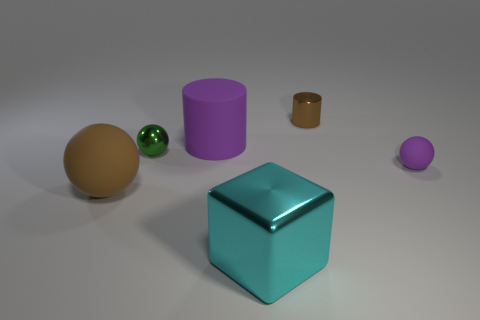Add 3 tiny rubber balls. How many objects exist? 9 Subtract all cubes. How many objects are left? 5 Add 4 brown matte spheres. How many brown matte spheres are left? 5 Add 1 small cyan rubber cubes. How many small cyan rubber cubes exist? 1 Subtract 0 gray blocks. How many objects are left? 6 Subtract all large brown balls. Subtract all tiny shiny cylinders. How many objects are left? 4 